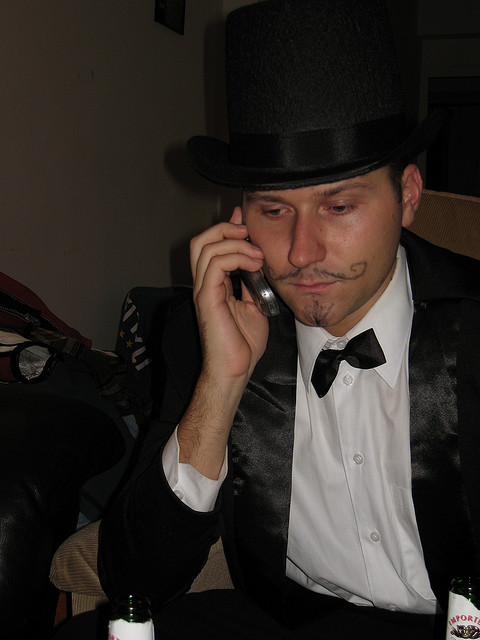What kind of phone is he using?
A. pay
B. rotary
C. landline
D. cellular
Answer with the option's letter from the given choices directly. D 